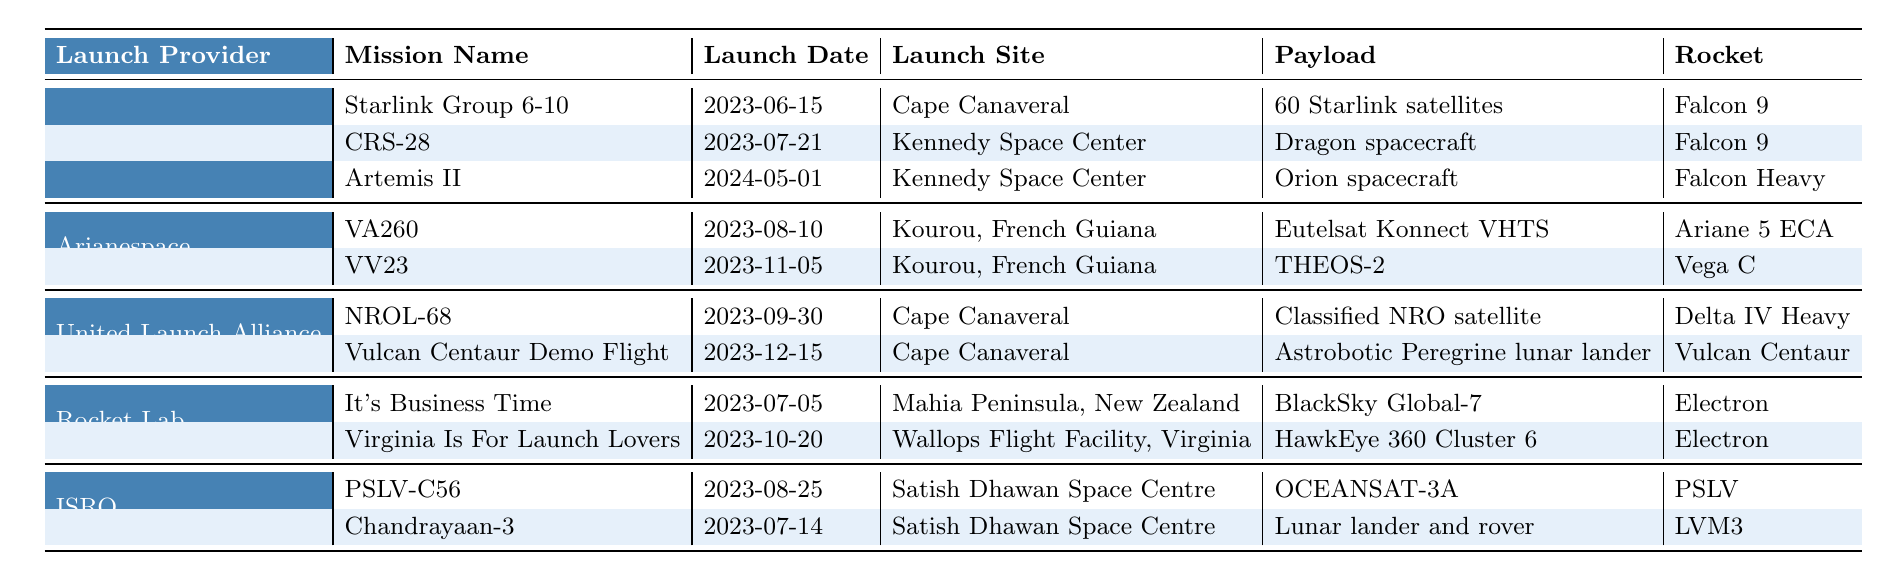What is the payload of the mission "Artemis II"? The table lists several missions, and under the entry for "Artemis II" in the "Payload" column, it shows "Orion spacecraft."
Answer: Orion spacecraft How many missions are scheduled by SpaceX? The table lists three missions under "SpaceX": "Starlink Group 6-10," "CRS-28," and "Artemis II." Counting these gives a total of three missions.
Answer: 3 Which launch provider has scheduled a launch on "2023-10-20"? Looking at the launch dates in the table, the entry for "2023-10-20" corresponds to "Virginia Is For Launch Lovers" under "Rocket Lab."
Answer: Rocket Lab Is there a mission scheduled on "2024-05-01"? Yes, the table indicates that "Artemis II" is scheduled for this date, under the "SpaceX" entry.
Answer: Yes What is the total number of launches scheduled in the month of August 2023? The table lists launches for ISRO (2 launches on the 14th and 25th) and Arianespace (1 launch on the 10th) in August, leading to a total of three launches.
Answer: 3 Which launch site has the most missions scheduled? By examining the table, "Cape Canaveral" appears under SpaceX and United Launch Alliance with a total of four missions, which is more than any other site.
Answer: Cape Canaveral Which rocket is used for the mission "NROL-68"? The table shows under the "NROL-68" mission that the rocket used is "Delta IV Heavy."
Answer: Delta IV Heavy What is the total number of missions listed under ISRO? The table shows that ISRO has two missions: "Chandrayaan-3" and "PSLV-C56," thereby totaling to two missions.
Answer: 2 What is the earliest scheduled launch date from the table? The earliest date listed is "2023-06-15" for the mission "Starlink Group 6-10" by SpaceX.
Answer: 2023-06-15 Are all missions using different payloads? No, "BlackSky Global-7" and "HawkEye 360 Cluster 6" listed under "Rocket Lab" are different payloads; however, there are other missions with unique payloads as well.
Answer: No Which mission has the longest interval between its launch date and the scheduled date among all listed missions? "Artemis II," with a launch date of "2024-05-01," has the longest interval as it is furthest into the future compared to all other missions, which are mainly in 2023.
Answer: Artemis II 